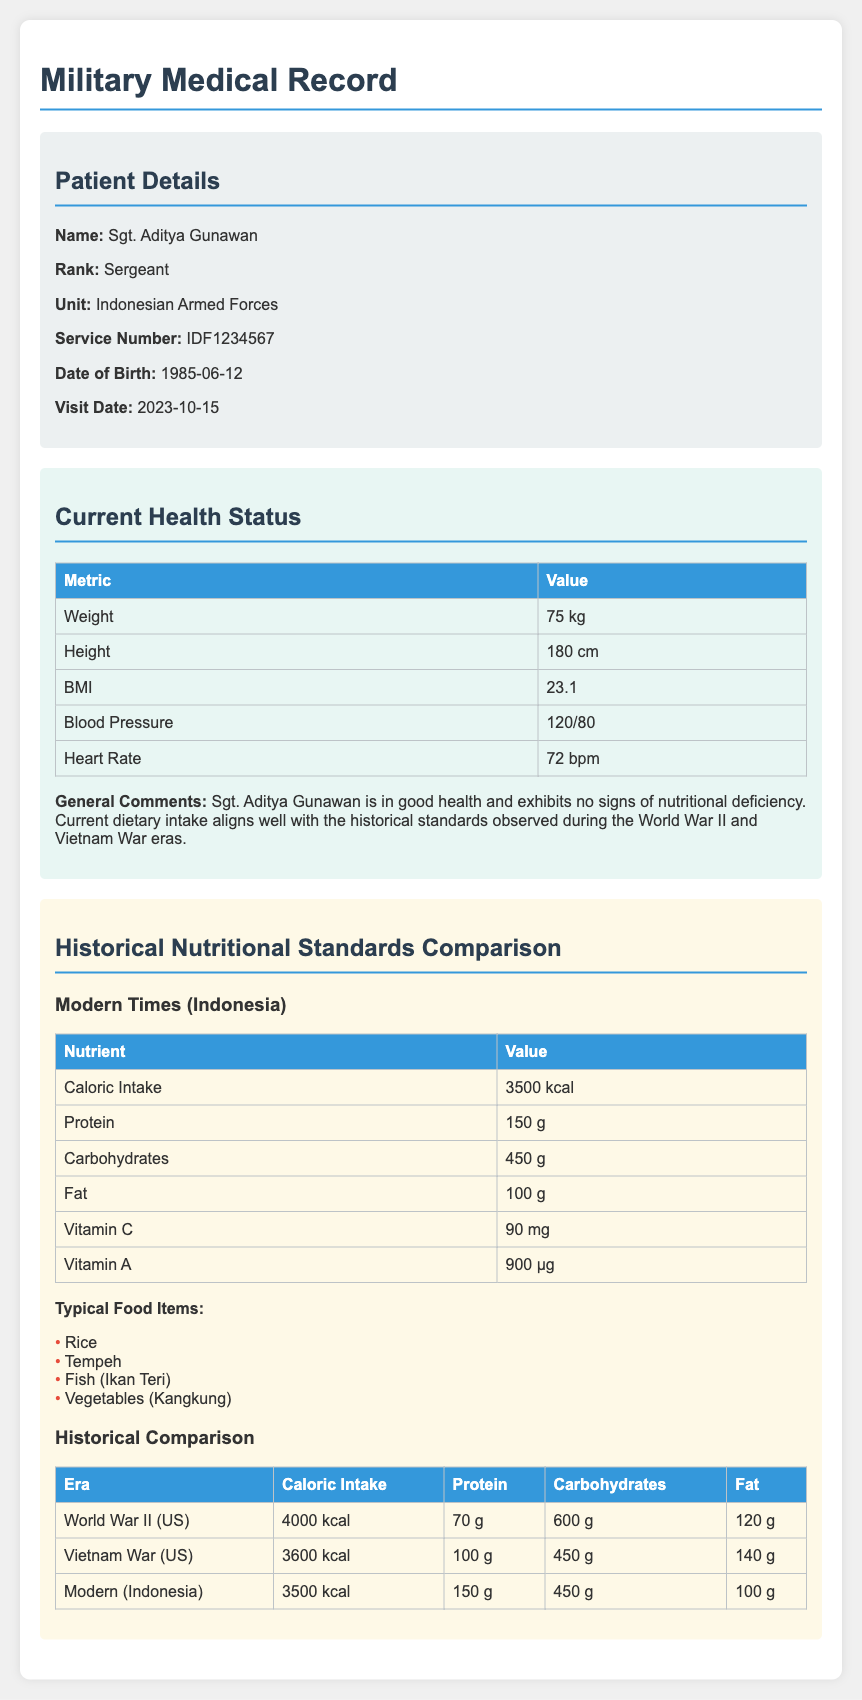What is the name of the patient? The patient's name is specifically stated in the document under Patient Details as Sgt. Aditya Gunawan.
Answer: Sgt. Aditya Gunawan What is the date of birth of the patient? The date of birth is explicitly mentioned in the patient information section.
Answer: 1985-06-12 What is the BMI of Sgt. Aditya Gunawan? The BMI is provided in the Current Health Status section, indicating the patient's body mass index.
Answer: 23.1 What was the caloric intake during World War II? The caloric intake for World War II is presented in the Historical Comparison table.
Answer: 4000 kcal How much protein is recommended in modern Indonesian soldier diets? The protein recommendation is detailed in the Modern Times table under Nutritional Standards Comparison.
Answer: 150 g What were the typical food items listed for the modern diet? The typical food items are listed under the Modern Times section as part of the dietary intake information.
Answer: Rice, Tempeh, Fish (Ikan Teri), Vegetables (Kangkung) What does the heart rate of Sgt. Aditya Gunawan indicate? The heart rate is part of the health status metrics, suggesting overall cardiovascular health.
Answer: 72 bpm What is the historical trend of caloric intake from World War II to modern times? The historical comparison shows distinct changes in caloric intake across different eras, indicating nutritional shifts over time.
Answer: Decrease from 4000 kcal to 3500 kcal What nutritional standard shows an increase when comparing modern diets to those from the Vietnam War? The table highlights the differing levels of protein intake across the eras, with modern standards showing a notable increase.
Answer: Protein 